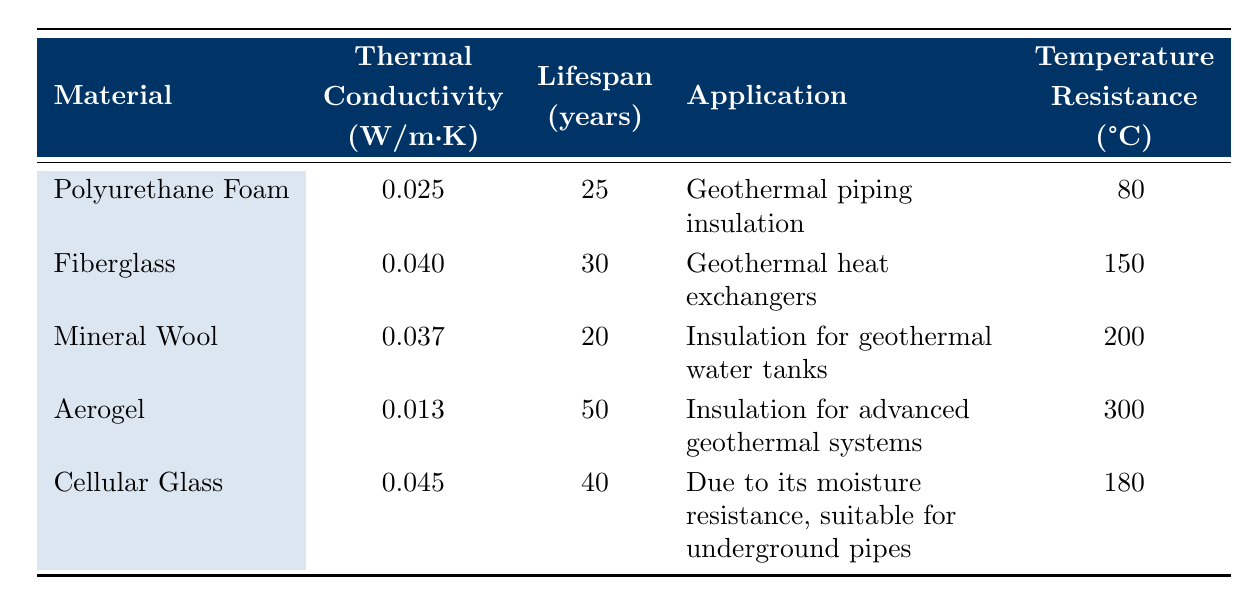What is the thermal conductivity of Aerogel? Looking at the table, the row for Aerogel shows a thermal conductivity value of 0.013 W/m·K.
Answer: 0.013 W/m·K Which insulating material has the longest lifespan? By inspecting the "Lifespan (years)" column, Aerogel has the highest lifespan value of 50 years, which is more than the other materials listed.
Answer: Aerogel Is the temperature resistance of Mineral Wool greater than that of Polyurethane Foam? The table indicates that Mineral Wool has a temperature resistance of 200°C while Polyurethane Foam has a temperature resistance of 80°C. Since 200°C is greater than 80°C, the statement is true.
Answer: Yes What is the average lifespan of all insulating materials listed? The lifespans of all materials are: 25, 30, 20, 50, and 40 years. To find the average, we sum these values (25 + 30 + 20 + 50 + 40 = 165) and divide by the number of materials (165 / 5 = 33).
Answer: 33 years Which insulating material is used for the highest temperature applications? From the table, Aerogel is indicated to be used for advanced geothermal systems and has the highest temperature resistance of 300°C across all materials listed.
Answer: Aerogel What is the difference in lifespan between Fiberglass and Cellular Glass? Fiberglass has a lifespan of 30 years, and Cellular Glass has a lifespan of 40 years. The difference can be calculated as 40 - 30 = 10 years.
Answer: 10 years Is Fiberglass suitable for geothermal piping insulation? The table specifies Fiberglass is used for geothermal heat exchangers, not piping insulation, so this statement is false.
Answer: No Which material has a greater thermal conductivity: Mineral Wool or Polyurethane Foam? From the table, Mineral Wool has a thermal conductivity of 0.037 W/m·K and Polyurethane Foam has a thermal conductivity of 0.025 W/m·K. Since 0.037 is greater than 0.025, Mineral Wool has the greater thermal conductivity.
Answer: Mineral Wool 